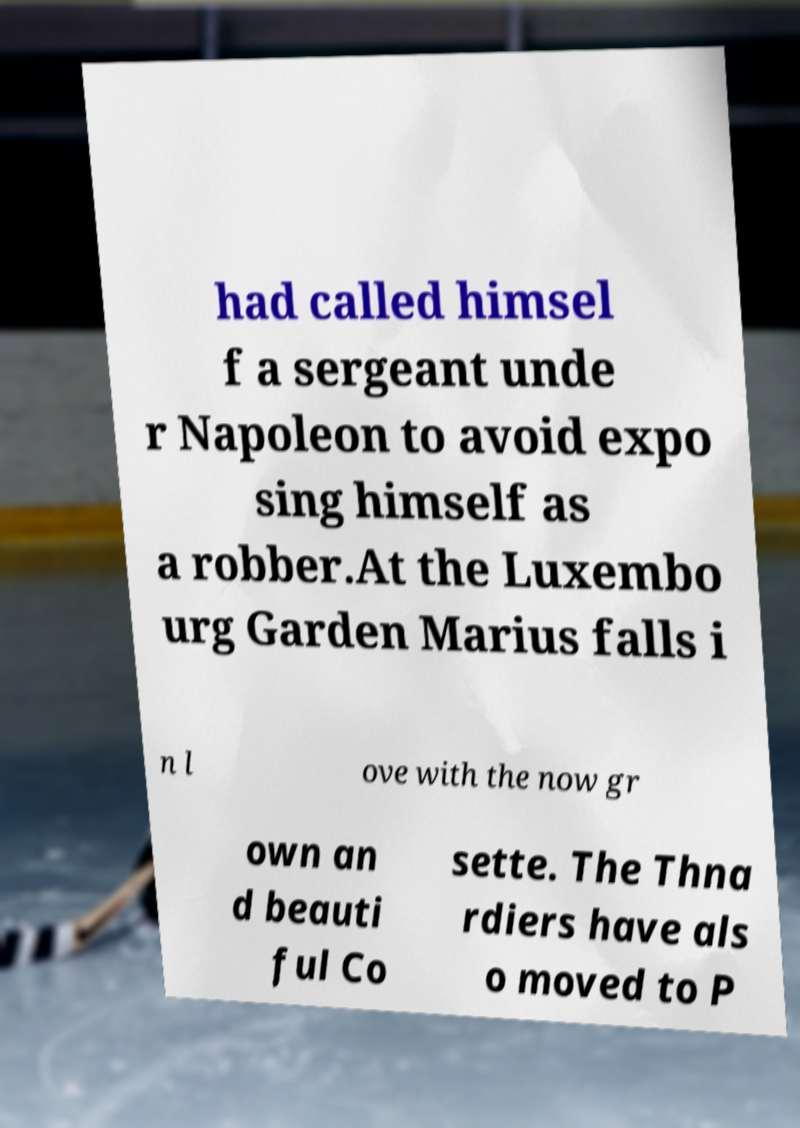What messages or text are displayed in this image? I need them in a readable, typed format. had called himsel f a sergeant unde r Napoleon to avoid expo sing himself as a robber.At the Luxembo urg Garden Marius falls i n l ove with the now gr own an d beauti ful Co sette. The Thna rdiers have als o moved to P 